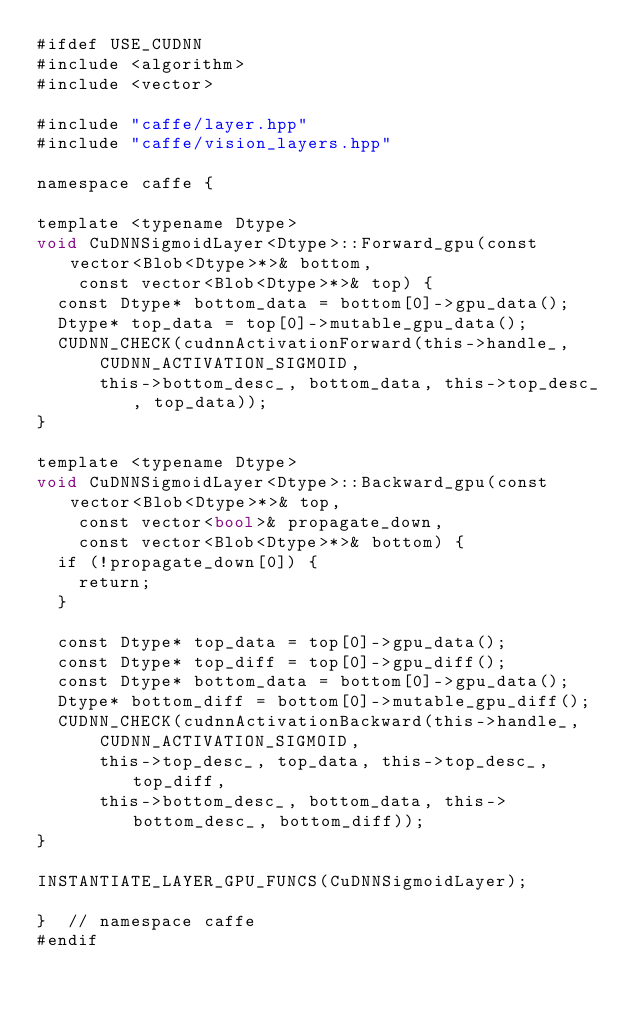<code> <loc_0><loc_0><loc_500><loc_500><_Cuda_>#ifdef USE_CUDNN
#include <algorithm>
#include <vector>

#include "caffe/layer.hpp"
#include "caffe/vision_layers.hpp"

namespace caffe {

template <typename Dtype>
void CuDNNSigmoidLayer<Dtype>::Forward_gpu(const vector<Blob<Dtype>*>& bottom,
    const vector<Blob<Dtype>*>& top) {
  const Dtype* bottom_data = bottom[0]->gpu_data();
  Dtype* top_data = top[0]->mutable_gpu_data();
  CUDNN_CHECK(cudnnActivationForward(this->handle_,
      CUDNN_ACTIVATION_SIGMOID,
      this->bottom_desc_, bottom_data, this->top_desc_, top_data));
}

template <typename Dtype>
void CuDNNSigmoidLayer<Dtype>::Backward_gpu(const vector<Blob<Dtype>*>& top,
    const vector<bool>& propagate_down,
    const vector<Blob<Dtype>*>& bottom) {
  if (!propagate_down[0]) {
    return;
  }

  const Dtype* top_data = top[0]->gpu_data();
  const Dtype* top_diff = top[0]->gpu_diff();
  const Dtype* bottom_data = bottom[0]->gpu_data();
  Dtype* bottom_diff = bottom[0]->mutable_gpu_diff();
  CUDNN_CHECK(cudnnActivationBackward(this->handle_,
      CUDNN_ACTIVATION_SIGMOID,
      this->top_desc_, top_data, this->top_desc_, top_diff,
      this->bottom_desc_, bottom_data, this->bottom_desc_, bottom_diff));
}

INSTANTIATE_LAYER_GPU_FUNCS(CuDNNSigmoidLayer);

}  // namespace caffe
#endif
</code> 